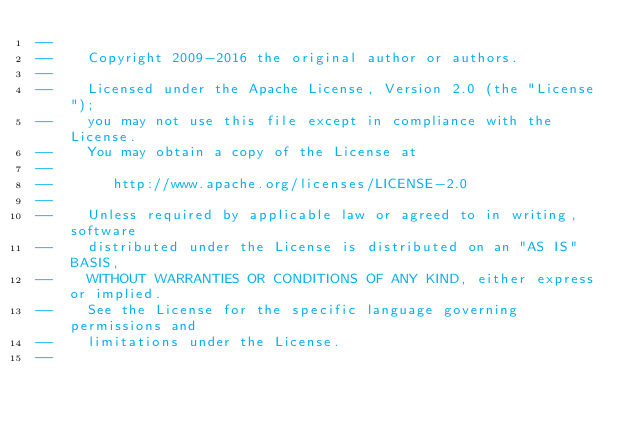<code> <loc_0><loc_0><loc_500><loc_500><_SQL_>--
--    Copyright 2009-2016 the original author or authors.
--
--    Licensed under the Apache License, Version 2.0 (the "License");
--    you may not use this file except in compliance with the License.
--    You may obtain a copy of the License at
--
--       http://www.apache.org/licenses/LICENSE-2.0
--
--    Unless required by applicable law or agreed to in writing, software
--    distributed under the License is distributed on an "AS IS" BASIS,
--    WITHOUT WARRANTIES OR CONDITIONS OF ANY KIND, either express or implied.
--    See the License for the specific language governing permissions and
--    limitations under the License.
--
</code> 